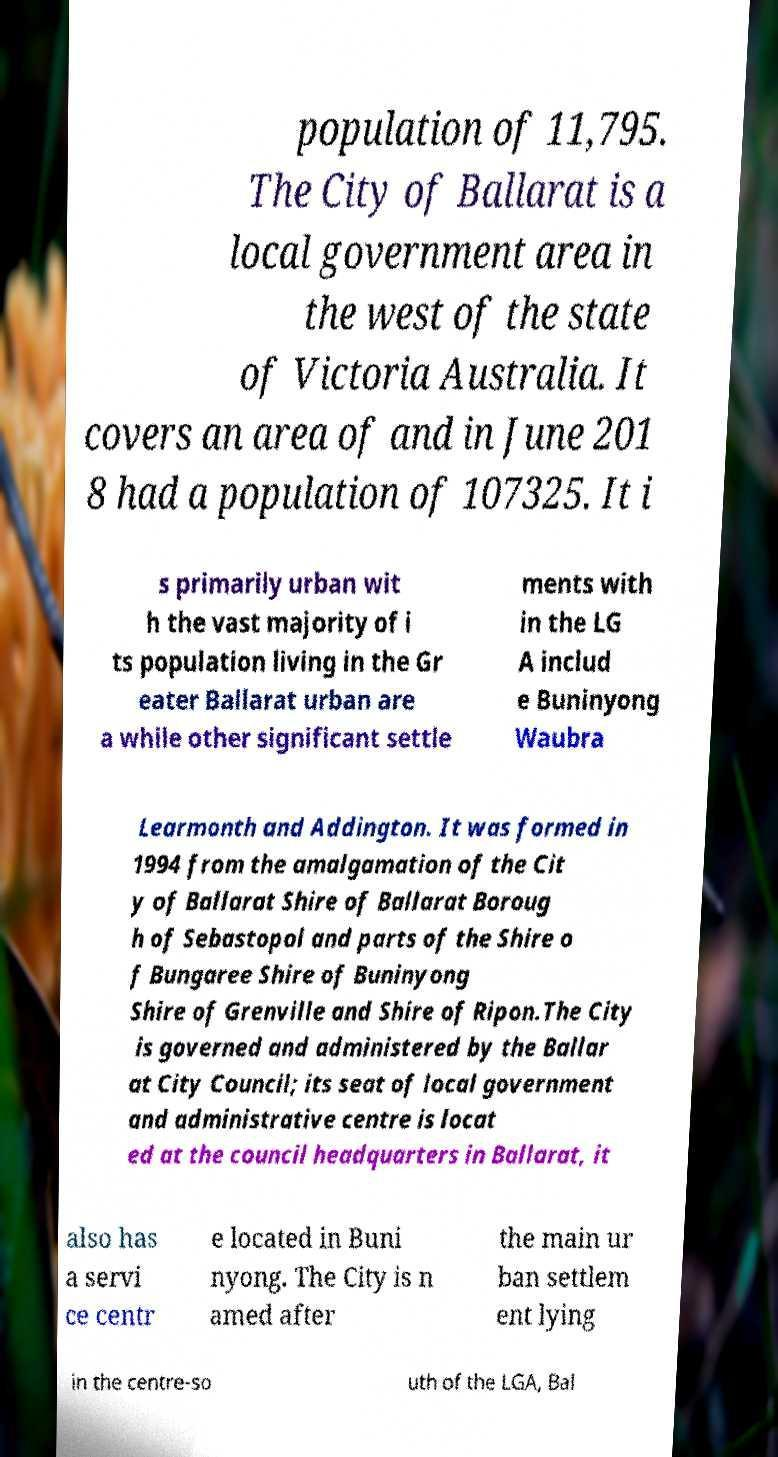What messages or text are displayed in this image? I need them in a readable, typed format. population of 11,795. The City of Ballarat is a local government area in the west of the state of Victoria Australia. It covers an area of and in June 201 8 had a population of 107325. It i s primarily urban wit h the vast majority of i ts population living in the Gr eater Ballarat urban are a while other significant settle ments with in the LG A includ e Buninyong Waubra Learmonth and Addington. It was formed in 1994 from the amalgamation of the Cit y of Ballarat Shire of Ballarat Boroug h of Sebastopol and parts of the Shire o f Bungaree Shire of Buninyong Shire of Grenville and Shire of Ripon.The City is governed and administered by the Ballar at City Council; its seat of local government and administrative centre is locat ed at the council headquarters in Ballarat, it also has a servi ce centr e located in Buni nyong. The City is n amed after the main ur ban settlem ent lying in the centre-so uth of the LGA, Bal 